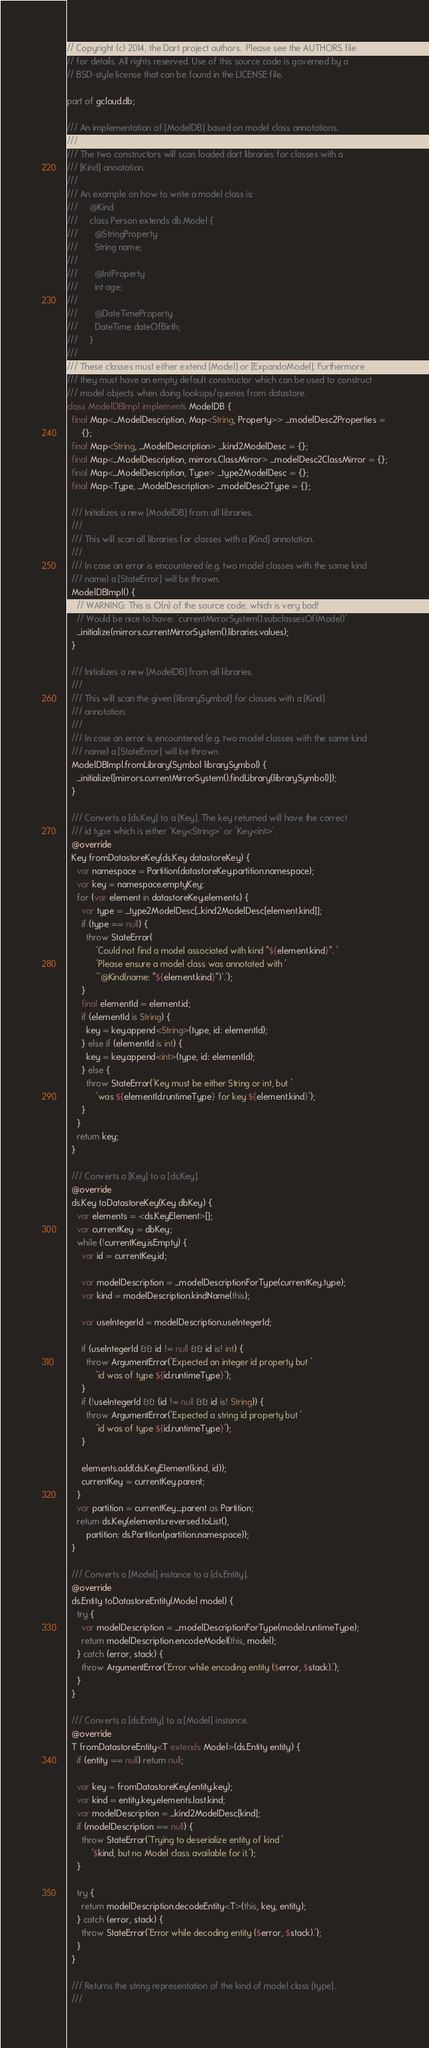Convert code to text. <code><loc_0><loc_0><loc_500><loc_500><_Dart_>// Copyright (c) 2014, the Dart project authors.  Please see the AUTHORS file
// for details. All rights reserved. Use of this source code is governed by a
// BSD-style license that can be found in the LICENSE file.

part of gcloud.db;

/// An implementation of [ModelDB] based on model class annotations.
///
/// The two constructors will scan loaded dart libraries for classes with a
/// [Kind] annotation.
///
/// An example on how to write a model class is:
///     @Kind
///     class Person extends db.Model {
///       @StringProperty
///       String name;
///
///       @IntProperty
///       int age;
///
///       @DateTimeProperty
///       DateTime dateOfBirth;
///     }
///
/// These classes must either extend [Model] or [ExpandoModel]. Furthermore
/// they must have an empty default constructor which can be used to construct
/// model objects when doing lookups/queries from datastore.
class ModelDBImpl implements ModelDB {
  final Map<_ModelDescription, Map<String, Property>> _modelDesc2Properties =
      {};
  final Map<String, _ModelDescription> _kind2ModelDesc = {};
  final Map<_ModelDescription, mirrors.ClassMirror> _modelDesc2ClassMirror = {};
  final Map<_ModelDescription, Type> _type2ModelDesc = {};
  final Map<Type, _ModelDescription> _modelDesc2Type = {};

  /// Initializes a new [ModelDB] from all libraries.
  ///
  /// This will scan all libraries for classes with a [Kind] annotation.
  ///
  /// In case an error is encountered (e.g. two model classes with the same kind
  /// name) a [StateError] will be thrown.
  ModelDBImpl() {
    // WARNING: This is O(n) of the source code, which is very bad!
    // Would be nice to have: `currentMirrorSystem().subclassesOf(Model)`
    _initialize(mirrors.currentMirrorSystem().libraries.values);
  }

  /// Initializes a new [ModelDB] from all libraries.
  ///
  /// This will scan the given [librarySymbol] for classes with a [Kind]
  /// annotation.
  ///
  /// In case an error is encountered (e.g. two model classes with the same kind
  /// name) a [StateError] will be thrown.
  ModelDBImpl.fromLibrary(Symbol librarySymbol) {
    _initialize([mirrors.currentMirrorSystem().findLibrary(librarySymbol)]);
  }

  /// Converts a [ds.Key] to a [Key]. The key returned will have the correct
  /// id type which is either `Key<String>` or `Key<int>`.
  @override
  Key fromDatastoreKey(ds.Key datastoreKey) {
    var namespace = Partition(datastoreKey.partition.namespace);
    var key = namespace.emptyKey;
    for (var element in datastoreKey.elements) {
      var type = _type2ModelDesc[_kind2ModelDesc[element.kind]];
      if (type == null) {
        throw StateError(
            'Could not find a model associated with kind "${element.kind}". '
            'Please ensure a model class was annotated with '
            '`@Kind(name: "${element.kind}")`.');
      }
      final elementId = element.id;
      if (elementId is String) {
        key = key.append<String>(type, id: elementId);
      } else if (elementId is int) {
        key = key.append<int>(type, id: elementId);
      } else {
        throw StateError('Key must be either String or int, but '
            'was ${elementId.runtimeType} for key ${element.kind}');
      }
    }
    return key;
  }

  /// Converts a [Key] to a [ds.Key].
  @override
  ds.Key toDatastoreKey(Key dbKey) {
    var elements = <ds.KeyElement>[];
    var currentKey = dbKey;
    while (!currentKey.isEmpty) {
      var id = currentKey.id;

      var modelDescription = _modelDescriptionForType(currentKey.type);
      var kind = modelDescription.kindName(this);

      var useIntegerId = modelDescription.useIntegerId;

      if (useIntegerId && id != null && id is! int) {
        throw ArgumentError('Expected an integer id property but '
            'id was of type ${id.runtimeType}');
      }
      if (!useIntegerId && (id != null && id is! String)) {
        throw ArgumentError('Expected a string id property but '
            'id was of type ${id.runtimeType}');
      }

      elements.add(ds.KeyElement(kind, id));
      currentKey = currentKey.parent;
    }
    var partition = currentKey._parent as Partition;
    return ds.Key(elements.reversed.toList(),
        partition: ds.Partition(partition.namespace));
  }

  /// Converts a [Model] instance to a [ds.Entity].
  @override
  ds.Entity toDatastoreEntity(Model model) {
    try {
      var modelDescription = _modelDescriptionForType(model.runtimeType);
      return modelDescription.encodeModel(this, model);
    } catch (error, stack) {
      throw ArgumentError('Error while encoding entity ($error, $stack).');
    }
  }

  /// Converts a [ds.Entity] to a [Model] instance.
  @override
  T fromDatastoreEntity<T extends Model>(ds.Entity entity) {
    if (entity == null) return null;

    var key = fromDatastoreKey(entity.key);
    var kind = entity.key.elements.last.kind;
    var modelDescription = _kind2ModelDesc[kind];
    if (modelDescription == null) {
      throw StateError('Trying to deserialize entity of kind '
          '$kind, but no Model class available for it.');
    }

    try {
      return modelDescription.decodeEntity<T>(this, key, entity);
    } catch (error, stack) {
      throw StateError('Error while decoding entity ($error, $stack).');
    }
  }

  /// Returns the string representation of the kind of model class [type].
  ///</code> 